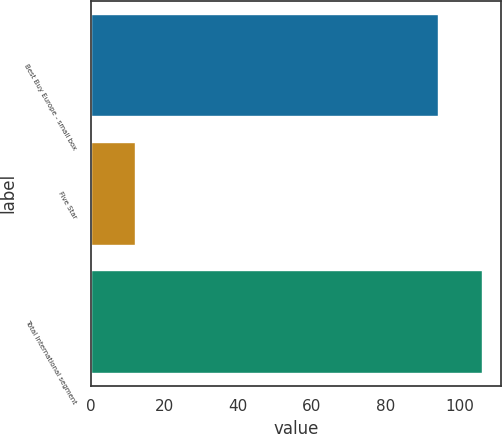Convert chart. <chart><loc_0><loc_0><loc_500><loc_500><bar_chart><fcel>Best Buy Europe - small box<fcel>Five Star<fcel>Total International segment<nl><fcel>94<fcel>12<fcel>106<nl></chart> 